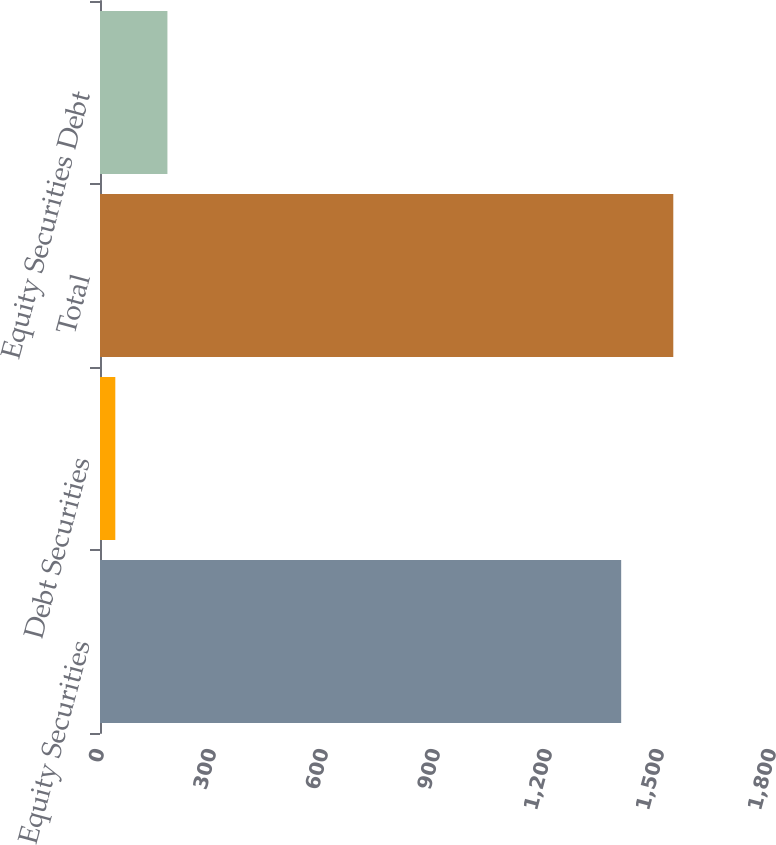Convert chart. <chart><loc_0><loc_0><loc_500><loc_500><bar_chart><fcel>Equity Securities<fcel>Debt Securities<fcel>Total<fcel>Equity Securities Debt<nl><fcel>1396<fcel>41<fcel>1535.6<fcel>180.6<nl></chart> 